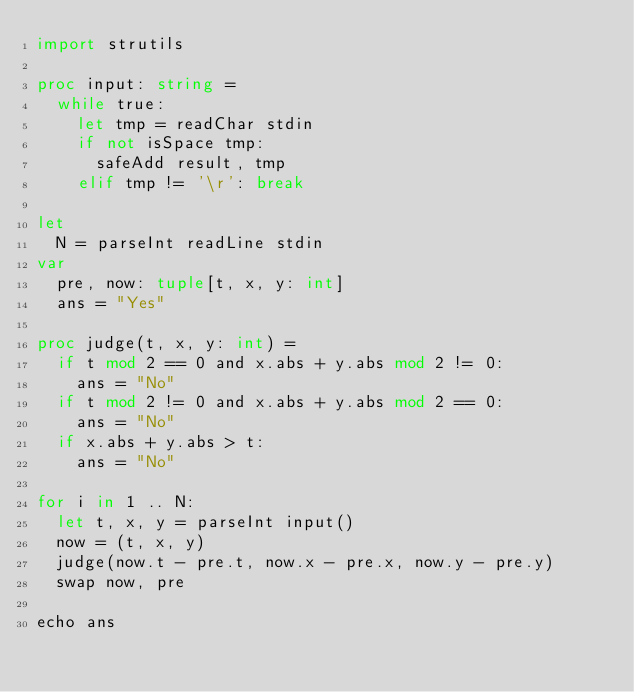<code> <loc_0><loc_0><loc_500><loc_500><_Nim_>import strutils

proc input: string =
  while true:
    let tmp = readChar stdin
    if not isSpace tmp:
      safeAdd result, tmp
    elif tmp != '\r': break

let
  N = parseInt readLine stdin
var
  pre, now: tuple[t, x, y: int]
  ans = "Yes"

proc judge(t, x, y: int) =
  if t mod 2 == 0 and x.abs + y.abs mod 2 != 0:
    ans = "No"
  if t mod 2 != 0 and x.abs + y.abs mod 2 == 0:
    ans = "No"
  if x.abs + y.abs > t:
    ans = "No"

for i in 1 .. N:
  let t, x, y = parseInt input()
  now = (t, x, y)
  judge(now.t - pre.t, now.x - pre.x, now.y - pre.y)
  swap now, pre

echo ans
</code> 